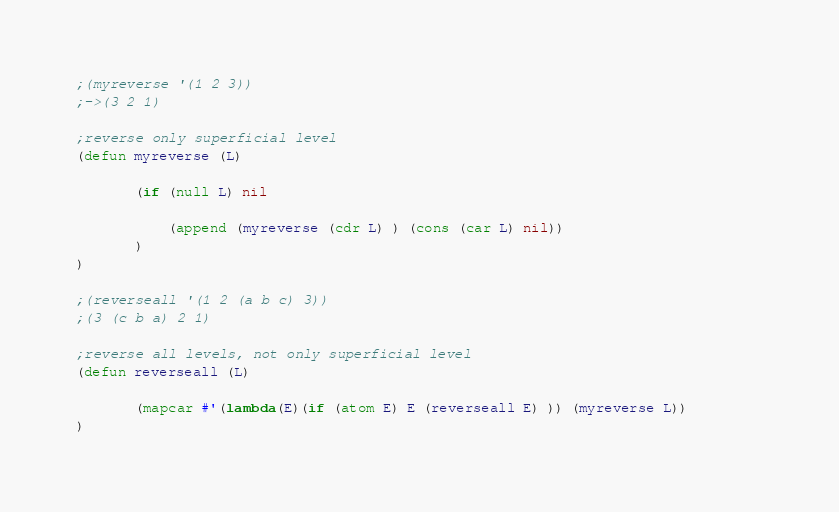Convert code to text. <code><loc_0><loc_0><loc_500><loc_500><_Lisp_>;(myreverse '(1 2 3))
;->(3 2 1)

;reverse only superficial level
(defun myreverse (L)

       (if (null L) nil 

           (append (myreverse (cdr L) ) (cons (car L) nil))
       )
)

;(reverseall '(1 2 (a b c) 3))
;(3 (c b a) 2 1)

;reverse all levels, not only superficial level
(defun reverseall (L)

       (mapcar #'(lambda(E)(if (atom E) E (reverseall E) )) (myreverse L))         
)</code> 